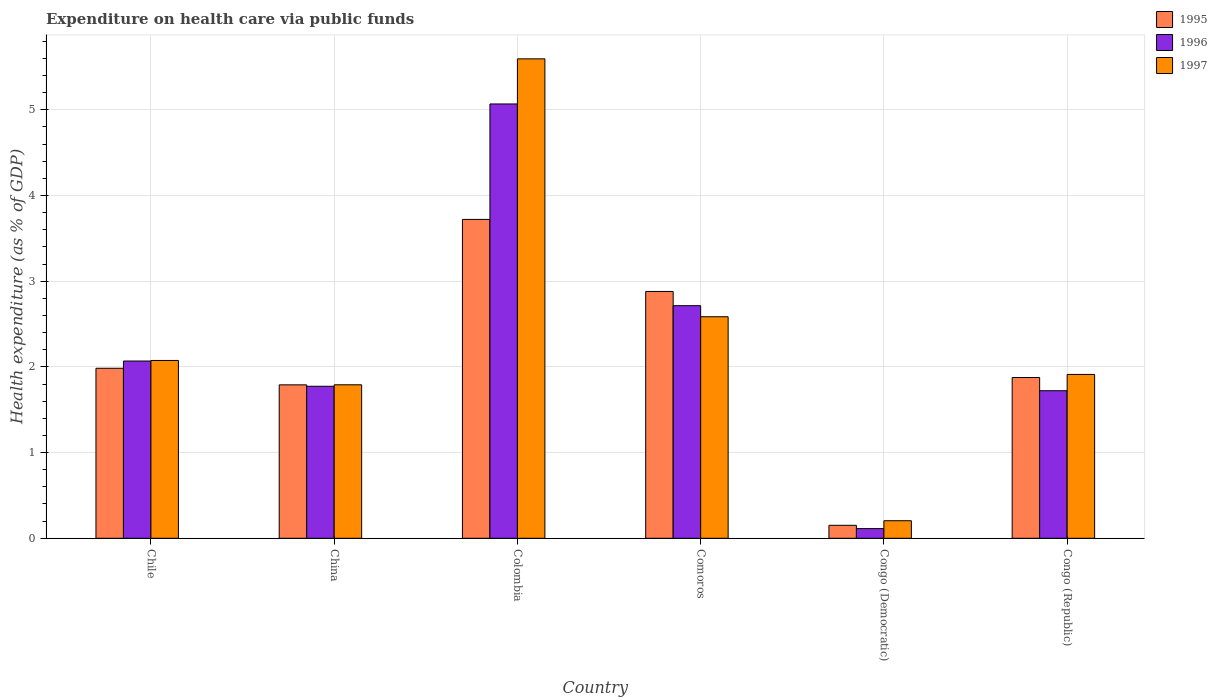Are the number of bars on each tick of the X-axis equal?
Give a very brief answer. Yes. How many bars are there on the 5th tick from the left?
Keep it short and to the point. 3. In how many cases, is the number of bars for a given country not equal to the number of legend labels?
Your answer should be very brief. 0. What is the expenditure made on health care in 1995 in China?
Provide a short and direct response. 1.79. Across all countries, what is the maximum expenditure made on health care in 1995?
Give a very brief answer. 3.72. Across all countries, what is the minimum expenditure made on health care in 1995?
Your answer should be very brief. 0.15. In which country was the expenditure made on health care in 1996 minimum?
Ensure brevity in your answer.  Congo (Democratic). What is the total expenditure made on health care in 1995 in the graph?
Keep it short and to the point. 12.4. What is the difference between the expenditure made on health care in 1995 in Colombia and that in Comoros?
Provide a succinct answer. 0.84. What is the difference between the expenditure made on health care in 1997 in Chile and the expenditure made on health care in 1995 in Congo (Republic)?
Keep it short and to the point. 0.2. What is the average expenditure made on health care in 1996 per country?
Offer a very short reply. 2.24. What is the difference between the expenditure made on health care of/in 1995 and expenditure made on health care of/in 1997 in Chile?
Your answer should be very brief. -0.09. What is the ratio of the expenditure made on health care in 1996 in Congo (Democratic) to that in Congo (Republic)?
Your response must be concise. 0.07. What is the difference between the highest and the second highest expenditure made on health care in 1996?
Make the answer very short. 0.65. What is the difference between the highest and the lowest expenditure made on health care in 1997?
Your answer should be compact. 5.39. What does the 2nd bar from the right in Congo (Democratic) represents?
Your answer should be very brief. 1996. How many countries are there in the graph?
Offer a very short reply. 6. What is the difference between two consecutive major ticks on the Y-axis?
Your response must be concise. 1. Does the graph contain grids?
Your answer should be compact. Yes. How are the legend labels stacked?
Keep it short and to the point. Vertical. What is the title of the graph?
Your response must be concise. Expenditure on health care via public funds. What is the label or title of the Y-axis?
Your response must be concise. Health expenditure (as % of GDP). What is the Health expenditure (as % of GDP) in 1995 in Chile?
Provide a short and direct response. 1.98. What is the Health expenditure (as % of GDP) of 1996 in Chile?
Your answer should be very brief. 2.07. What is the Health expenditure (as % of GDP) in 1997 in Chile?
Ensure brevity in your answer.  2.07. What is the Health expenditure (as % of GDP) of 1995 in China?
Keep it short and to the point. 1.79. What is the Health expenditure (as % of GDP) of 1996 in China?
Ensure brevity in your answer.  1.77. What is the Health expenditure (as % of GDP) of 1997 in China?
Make the answer very short. 1.79. What is the Health expenditure (as % of GDP) of 1995 in Colombia?
Provide a succinct answer. 3.72. What is the Health expenditure (as % of GDP) of 1996 in Colombia?
Keep it short and to the point. 5.07. What is the Health expenditure (as % of GDP) in 1997 in Colombia?
Your answer should be compact. 5.59. What is the Health expenditure (as % of GDP) of 1995 in Comoros?
Ensure brevity in your answer.  2.88. What is the Health expenditure (as % of GDP) in 1996 in Comoros?
Your answer should be very brief. 2.71. What is the Health expenditure (as % of GDP) in 1997 in Comoros?
Give a very brief answer. 2.58. What is the Health expenditure (as % of GDP) of 1995 in Congo (Democratic)?
Keep it short and to the point. 0.15. What is the Health expenditure (as % of GDP) of 1996 in Congo (Democratic)?
Your answer should be compact. 0.11. What is the Health expenditure (as % of GDP) of 1997 in Congo (Democratic)?
Offer a terse response. 0.2. What is the Health expenditure (as % of GDP) of 1995 in Congo (Republic)?
Your response must be concise. 1.88. What is the Health expenditure (as % of GDP) in 1996 in Congo (Republic)?
Your response must be concise. 1.72. What is the Health expenditure (as % of GDP) in 1997 in Congo (Republic)?
Keep it short and to the point. 1.91. Across all countries, what is the maximum Health expenditure (as % of GDP) in 1995?
Keep it short and to the point. 3.72. Across all countries, what is the maximum Health expenditure (as % of GDP) in 1996?
Your answer should be very brief. 5.07. Across all countries, what is the maximum Health expenditure (as % of GDP) of 1997?
Provide a succinct answer. 5.59. Across all countries, what is the minimum Health expenditure (as % of GDP) in 1995?
Offer a terse response. 0.15. Across all countries, what is the minimum Health expenditure (as % of GDP) in 1996?
Provide a succinct answer. 0.11. Across all countries, what is the minimum Health expenditure (as % of GDP) in 1997?
Offer a terse response. 0.2. What is the total Health expenditure (as % of GDP) in 1995 in the graph?
Your response must be concise. 12.4. What is the total Health expenditure (as % of GDP) of 1996 in the graph?
Your answer should be compact. 13.46. What is the total Health expenditure (as % of GDP) in 1997 in the graph?
Ensure brevity in your answer.  14.16. What is the difference between the Health expenditure (as % of GDP) in 1995 in Chile and that in China?
Your response must be concise. 0.19. What is the difference between the Health expenditure (as % of GDP) in 1996 in Chile and that in China?
Ensure brevity in your answer.  0.29. What is the difference between the Health expenditure (as % of GDP) in 1997 in Chile and that in China?
Provide a short and direct response. 0.28. What is the difference between the Health expenditure (as % of GDP) of 1995 in Chile and that in Colombia?
Provide a succinct answer. -1.74. What is the difference between the Health expenditure (as % of GDP) in 1996 in Chile and that in Colombia?
Your answer should be compact. -3. What is the difference between the Health expenditure (as % of GDP) in 1997 in Chile and that in Colombia?
Provide a succinct answer. -3.52. What is the difference between the Health expenditure (as % of GDP) of 1995 in Chile and that in Comoros?
Your response must be concise. -0.9. What is the difference between the Health expenditure (as % of GDP) in 1996 in Chile and that in Comoros?
Make the answer very short. -0.65. What is the difference between the Health expenditure (as % of GDP) of 1997 in Chile and that in Comoros?
Offer a terse response. -0.51. What is the difference between the Health expenditure (as % of GDP) in 1995 in Chile and that in Congo (Democratic)?
Your answer should be compact. 1.83. What is the difference between the Health expenditure (as % of GDP) in 1996 in Chile and that in Congo (Democratic)?
Offer a very short reply. 1.96. What is the difference between the Health expenditure (as % of GDP) of 1997 in Chile and that in Congo (Democratic)?
Your response must be concise. 1.87. What is the difference between the Health expenditure (as % of GDP) in 1995 in Chile and that in Congo (Republic)?
Provide a short and direct response. 0.11. What is the difference between the Health expenditure (as % of GDP) in 1996 in Chile and that in Congo (Republic)?
Your response must be concise. 0.35. What is the difference between the Health expenditure (as % of GDP) of 1997 in Chile and that in Congo (Republic)?
Your answer should be compact. 0.16. What is the difference between the Health expenditure (as % of GDP) in 1995 in China and that in Colombia?
Your answer should be compact. -1.93. What is the difference between the Health expenditure (as % of GDP) of 1996 in China and that in Colombia?
Offer a very short reply. -3.29. What is the difference between the Health expenditure (as % of GDP) in 1997 in China and that in Colombia?
Your answer should be very brief. -3.8. What is the difference between the Health expenditure (as % of GDP) of 1995 in China and that in Comoros?
Your response must be concise. -1.09. What is the difference between the Health expenditure (as % of GDP) in 1996 in China and that in Comoros?
Provide a short and direct response. -0.94. What is the difference between the Health expenditure (as % of GDP) of 1997 in China and that in Comoros?
Provide a succinct answer. -0.79. What is the difference between the Health expenditure (as % of GDP) of 1995 in China and that in Congo (Democratic)?
Provide a short and direct response. 1.64. What is the difference between the Health expenditure (as % of GDP) of 1996 in China and that in Congo (Democratic)?
Ensure brevity in your answer.  1.66. What is the difference between the Health expenditure (as % of GDP) in 1997 in China and that in Congo (Democratic)?
Ensure brevity in your answer.  1.59. What is the difference between the Health expenditure (as % of GDP) of 1995 in China and that in Congo (Republic)?
Your answer should be very brief. -0.09. What is the difference between the Health expenditure (as % of GDP) in 1996 in China and that in Congo (Republic)?
Your answer should be very brief. 0.05. What is the difference between the Health expenditure (as % of GDP) of 1997 in China and that in Congo (Republic)?
Your answer should be compact. -0.12. What is the difference between the Health expenditure (as % of GDP) of 1995 in Colombia and that in Comoros?
Make the answer very short. 0.84. What is the difference between the Health expenditure (as % of GDP) in 1996 in Colombia and that in Comoros?
Provide a succinct answer. 2.35. What is the difference between the Health expenditure (as % of GDP) of 1997 in Colombia and that in Comoros?
Offer a very short reply. 3.01. What is the difference between the Health expenditure (as % of GDP) of 1995 in Colombia and that in Congo (Democratic)?
Your answer should be very brief. 3.57. What is the difference between the Health expenditure (as % of GDP) in 1996 in Colombia and that in Congo (Democratic)?
Your answer should be very brief. 4.95. What is the difference between the Health expenditure (as % of GDP) in 1997 in Colombia and that in Congo (Democratic)?
Provide a short and direct response. 5.39. What is the difference between the Health expenditure (as % of GDP) in 1995 in Colombia and that in Congo (Republic)?
Your response must be concise. 1.84. What is the difference between the Health expenditure (as % of GDP) of 1996 in Colombia and that in Congo (Republic)?
Your response must be concise. 3.35. What is the difference between the Health expenditure (as % of GDP) in 1997 in Colombia and that in Congo (Republic)?
Keep it short and to the point. 3.68. What is the difference between the Health expenditure (as % of GDP) of 1995 in Comoros and that in Congo (Democratic)?
Your answer should be very brief. 2.73. What is the difference between the Health expenditure (as % of GDP) in 1996 in Comoros and that in Congo (Democratic)?
Your response must be concise. 2.6. What is the difference between the Health expenditure (as % of GDP) of 1997 in Comoros and that in Congo (Democratic)?
Offer a very short reply. 2.38. What is the difference between the Health expenditure (as % of GDP) in 1995 in Comoros and that in Congo (Republic)?
Your answer should be compact. 1. What is the difference between the Health expenditure (as % of GDP) in 1997 in Comoros and that in Congo (Republic)?
Ensure brevity in your answer.  0.67. What is the difference between the Health expenditure (as % of GDP) in 1995 in Congo (Democratic) and that in Congo (Republic)?
Give a very brief answer. -1.72. What is the difference between the Health expenditure (as % of GDP) in 1996 in Congo (Democratic) and that in Congo (Republic)?
Keep it short and to the point. -1.61. What is the difference between the Health expenditure (as % of GDP) of 1997 in Congo (Democratic) and that in Congo (Republic)?
Offer a very short reply. -1.71. What is the difference between the Health expenditure (as % of GDP) in 1995 in Chile and the Health expenditure (as % of GDP) in 1996 in China?
Give a very brief answer. 0.21. What is the difference between the Health expenditure (as % of GDP) in 1995 in Chile and the Health expenditure (as % of GDP) in 1997 in China?
Give a very brief answer. 0.19. What is the difference between the Health expenditure (as % of GDP) of 1996 in Chile and the Health expenditure (as % of GDP) of 1997 in China?
Your answer should be very brief. 0.28. What is the difference between the Health expenditure (as % of GDP) in 1995 in Chile and the Health expenditure (as % of GDP) in 1996 in Colombia?
Your response must be concise. -3.08. What is the difference between the Health expenditure (as % of GDP) in 1995 in Chile and the Health expenditure (as % of GDP) in 1997 in Colombia?
Your answer should be compact. -3.61. What is the difference between the Health expenditure (as % of GDP) in 1996 in Chile and the Health expenditure (as % of GDP) in 1997 in Colombia?
Provide a short and direct response. -3.53. What is the difference between the Health expenditure (as % of GDP) of 1995 in Chile and the Health expenditure (as % of GDP) of 1996 in Comoros?
Provide a short and direct response. -0.73. What is the difference between the Health expenditure (as % of GDP) in 1995 in Chile and the Health expenditure (as % of GDP) in 1997 in Comoros?
Offer a terse response. -0.6. What is the difference between the Health expenditure (as % of GDP) in 1996 in Chile and the Health expenditure (as % of GDP) in 1997 in Comoros?
Your answer should be very brief. -0.52. What is the difference between the Health expenditure (as % of GDP) of 1995 in Chile and the Health expenditure (as % of GDP) of 1996 in Congo (Democratic)?
Provide a succinct answer. 1.87. What is the difference between the Health expenditure (as % of GDP) in 1995 in Chile and the Health expenditure (as % of GDP) in 1997 in Congo (Democratic)?
Offer a very short reply. 1.78. What is the difference between the Health expenditure (as % of GDP) of 1996 in Chile and the Health expenditure (as % of GDP) of 1997 in Congo (Democratic)?
Provide a succinct answer. 1.86. What is the difference between the Health expenditure (as % of GDP) of 1995 in Chile and the Health expenditure (as % of GDP) of 1996 in Congo (Republic)?
Offer a terse response. 0.26. What is the difference between the Health expenditure (as % of GDP) of 1995 in Chile and the Health expenditure (as % of GDP) of 1997 in Congo (Republic)?
Ensure brevity in your answer.  0.07. What is the difference between the Health expenditure (as % of GDP) of 1996 in Chile and the Health expenditure (as % of GDP) of 1997 in Congo (Republic)?
Provide a short and direct response. 0.16. What is the difference between the Health expenditure (as % of GDP) of 1995 in China and the Health expenditure (as % of GDP) of 1996 in Colombia?
Provide a succinct answer. -3.28. What is the difference between the Health expenditure (as % of GDP) in 1995 in China and the Health expenditure (as % of GDP) in 1997 in Colombia?
Your answer should be very brief. -3.8. What is the difference between the Health expenditure (as % of GDP) of 1996 in China and the Health expenditure (as % of GDP) of 1997 in Colombia?
Give a very brief answer. -3.82. What is the difference between the Health expenditure (as % of GDP) in 1995 in China and the Health expenditure (as % of GDP) in 1996 in Comoros?
Offer a terse response. -0.92. What is the difference between the Health expenditure (as % of GDP) in 1995 in China and the Health expenditure (as % of GDP) in 1997 in Comoros?
Keep it short and to the point. -0.79. What is the difference between the Health expenditure (as % of GDP) of 1996 in China and the Health expenditure (as % of GDP) of 1997 in Comoros?
Offer a terse response. -0.81. What is the difference between the Health expenditure (as % of GDP) of 1995 in China and the Health expenditure (as % of GDP) of 1996 in Congo (Democratic)?
Make the answer very short. 1.68. What is the difference between the Health expenditure (as % of GDP) of 1995 in China and the Health expenditure (as % of GDP) of 1997 in Congo (Democratic)?
Offer a very short reply. 1.59. What is the difference between the Health expenditure (as % of GDP) of 1996 in China and the Health expenditure (as % of GDP) of 1997 in Congo (Democratic)?
Ensure brevity in your answer.  1.57. What is the difference between the Health expenditure (as % of GDP) of 1995 in China and the Health expenditure (as % of GDP) of 1996 in Congo (Republic)?
Your answer should be very brief. 0.07. What is the difference between the Health expenditure (as % of GDP) in 1995 in China and the Health expenditure (as % of GDP) in 1997 in Congo (Republic)?
Provide a short and direct response. -0.12. What is the difference between the Health expenditure (as % of GDP) of 1996 in China and the Health expenditure (as % of GDP) of 1997 in Congo (Republic)?
Provide a short and direct response. -0.14. What is the difference between the Health expenditure (as % of GDP) in 1995 in Colombia and the Health expenditure (as % of GDP) in 1996 in Comoros?
Provide a short and direct response. 1.01. What is the difference between the Health expenditure (as % of GDP) in 1995 in Colombia and the Health expenditure (as % of GDP) in 1997 in Comoros?
Your answer should be compact. 1.14. What is the difference between the Health expenditure (as % of GDP) of 1996 in Colombia and the Health expenditure (as % of GDP) of 1997 in Comoros?
Offer a terse response. 2.48. What is the difference between the Health expenditure (as % of GDP) in 1995 in Colombia and the Health expenditure (as % of GDP) in 1996 in Congo (Democratic)?
Provide a short and direct response. 3.61. What is the difference between the Health expenditure (as % of GDP) of 1995 in Colombia and the Health expenditure (as % of GDP) of 1997 in Congo (Democratic)?
Your response must be concise. 3.52. What is the difference between the Health expenditure (as % of GDP) of 1996 in Colombia and the Health expenditure (as % of GDP) of 1997 in Congo (Democratic)?
Provide a succinct answer. 4.86. What is the difference between the Health expenditure (as % of GDP) of 1995 in Colombia and the Health expenditure (as % of GDP) of 1996 in Congo (Republic)?
Make the answer very short. 2. What is the difference between the Health expenditure (as % of GDP) of 1995 in Colombia and the Health expenditure (as % of GDP) of 1997 in Congo (Republic)?
Keep it short and to the point. 1.81. What is the difference between the Health expenditure (as % of GDP) in 1996 in Colombia and the Health expenditure (as % of GDP) in 1997 in Congo (Republic)?
Your answer should be very brief. 3.16. What is the difference between the Health expenditure (as % of GDP) of 1995 in Comoros and the Health expenditure (as % of GDP) of 1996 in Congo (Democratic)?
Your response must be concise. 2.77. What is the difference between the Health expenditure (as % of GDP) in 1995 in Comoros and the Health expenditure (as % of GDP) in 1997 in Congo (Democratic)?
Keep it short and to the point. 2.67. What is the difference between the Health expenditure (as % of GDP) in 1996 in Comoros and the Health expenditure (as % of GDP) in 1997 in Congo (Democratic)?
Keep it short and to the point. 2.51. What is the difference between the Health expenditure (as % of GDP) in 1995 in Comoros and the Health expenditure (as % of GDP) in 1996 in Congo (Republic)?
Provide a short and direct response. 1.16. What is the difference between the Health expenditure (as % of GDP) in 1995 in Comoros and the Health expenditure (as % of GDP) in 1997 in Congo (Republic)?
Provide a short and direct response. 0.97. What is the difference between the Health expenditure (as % of GDP) in 1996 in Comoros and the Health expenditure (as % of GDP) in 1997 in Congo (Republic)?
Your answer should be compact. 0.8. What is the difference between the Health expenditure (as % of GDP) of 1995 in Congo (Democratic) and the Health expenditure (as % of GDP) of 1996 in Congo (Republic)?
Your response must be concise. -1.57. What is the difference between the Health expenditure (as % of GDP) in 1995 in Congo (Democratic) and the Health expenditure (as % of GDP) in 1997 in Congo (Republic)?
Provide a short and direct response. -1.76. What is the difference between the Health expenditure (as % of GDP) of 1996 in Congo (Democratic) and the Health expenditure (as % of GDP) of 1997 in Congo (Republic)?
Your response must be concise. -1.8. What is the average Health expenditure (as % of GDP) in 1995 per country?
Give a very brief answer. 2.07. What is the average Health expenditure (as % of GDP) in 1996 per country?
Offer a very short reply. 2.24. What is the average Health expenditure (as % of GDP) in 1997 per country?
Give a very brief answer. 2.36. What is the difference between the Health expenditure (as % of GDP) in 1995 and Health expenditure (as % of GDP) in 1996 in Chile?
Provide a short and direct response. -0.08. What is the difference between the Health expenditure (as % of GDP) of 1995 and Health expenditure (as % of GDP) of 1997 in Chile?
Your answer should be compact. -0.09. What is the difference between the Health expenditure (as % of GDP) of 1996 and Health expenditure (as % of GDP) of 1997 in Chile?
Give a very brief answer. -0.01. What is the difference between the Health expenditure (as % of GDP) in 1995 and Health expenditure (as % of GDP) in 1996 in China?
Offer a very short reply. 0.02. What is the difference between the Health expenditure (as % of GDP) in 1995 and Health expenditure (as % of GDP) in 1997 in China?
Ensure brevity in your answer.  -0. What is the difference between the Health expenditure (as % of GDP) in 1996 and Health expenditure (as % of GDP) in 1997 in China?
Keep it short and to the point. -0.02. What is the difference between the Health expenditure (as % of GDP) of 1995 and Health expenditure (as % of GDP) of 1996 in Colombia?
Your answer should be very brief. -1.35. What is the difference between the Health expenditure (as % of GDP) in 1995 and Health expenditure (as % of GDP) in 1997 in Colombia?
Your answer should be compact. -1.87. What is the difference between the Health expenditure (as % of GDP) of 1996 and Health expenditure (as % of GDP) of 1997 in Colombia?
Your answer should be very brief. -0.53. What is the difference between the Health expenditure (as % of GDP) of 1995 and Health expenditure (as % of GDP) of 1996 in Comoros?
Offer a terse response. 0.17. What is the difference between the Health expenditure (as % of GDP) of 1995 and Health expenditure (as % of GDP) of 1997 in Comoros?
Provide a succinct answer. 0.29. What is the difference between the Health expenditure (as % of GDP) of 1996 and Health expenditure (as % of GDP) of 1997 in Comoros?
Give a very brief answer. 0.13. What is the difference between the Health expenditure (as % of GDP) of 1995 and Health expenditure (as % of GDP) of 1996 in Congo (Democratic)?
Ensure brevity in your answer.  0.04. What is the difference between the Health expenditure (as % of GDP) in 1995 and Health expenditure (as % of GDP) in 1997 in Congo (Democratic)?
Make the answer very short. -0.05. What is the difference between the Health expenditure (as % of GDP) in 1996 and Health expenditure (as % of GDP) in 1997 in Congo (Democratic)?
Provide a short and direct response. -0.09. What is the difference between the Health expenditure (as % of GDP) in 1995 and Health expenditure (as % of GDP) in 1996 in Congo (Republic)?
Provide a succinct answer. 0.15. What is the difference between the Health expenditure (as % of GDP) in 1995 and Health expenditure (as % of GDP) in 1997 in Congo (Republic)?
Offer a terse response. -0.04. What is the difference between the Health expenditure (as % of GDP) in 1996 and Health expenditure (as % of GDP) in 1997 in Congo (Republic)?
Your response must be concise. -0.19. What is the ratio of the Health expenditure (as % of GDP) of 1995 in Chile to that in China?
Make the answer very short. 1.11. What is the ratio of the Health expenditure (as % of GDP) of 1996 in Chile to that in China?
Provide a short and direct response. 1.17. What is the ratio of the Health expenditure (as % of GDP) in 1997 in Chile to that in China?
Make the answer very short. 1.16. What is the ratio of the Health expenditure (as % of GDP) in 1995 in Chile to that in Colombia?
Give a very brief answer. 0.53. What is the ratio of the Health expenditure (as % of GDP) in 1996 in Chile to that in Colombia?
Provide a succinct answer. 0.41. What is the ratio of the Health expenditure (as % of GDP) in 1997 in Chile to that in Colombia?
Your answer should be compact. 0.37. What is the ratio of the Health expenditure (as % of GDP) in 1995 in Chile to that in Comoros?
Keep it short and to the point. 0.69. What is the ratio of the Health expenditure (as % of GDP) in 1996 in Chile to that in Comoros?
Keep it short and to the point. 0.76. What is the ratio of the Health expenditure (as % of GDP) of 1997 in Chile to that in Comoros?
Offer a terse response. 0.8. What is the ratio of the Health expenditure (as % of GDP) in 1995 in Chile to that in Congo (Democratic)?
Ensure brevity in your answer.  13.1. What is the ratio of the Health expenditure (as % of GDP) of 1996 in Chile to that in Congo (Democratic)?
Your response must be concise. 18.3. What is the ratio of the Health expenditure (as % of GDP) of 1997 in Chile to that in Congo (Democratic)?
Your response must be concise. 10.13. What is the ratio of the Health expenditure (as % of GDP) of 1995 in Chile to that in Congo (Republic)?
Your answer should be very brief. 1.06. What is the ratio of the Health expenditure (as % of GDP) of 1996 in Chile to that in Congo (Republic)?
Keep it short and to the point. 1.2. What is the ratio of the Health expenditure (as % of GDP) in 1997 in Chile to that in Congo (Republic)?
Your answer should be compact. 1.09. What is the ratio of the Health expenditure (as % of GDP) in 1995 in China to that in Colombia?
Offer a very short reply. 0.48. What is the ratio of the Health expenditure (as % of GDP) of 1997 in China to that in Colombia?
Keep it short and to the point. 0.32. What is the ratio of the Health expenditure (as % of GDP) in 1995 in China to that in Comoros?
Your answer should be very brief. 0.62. What is the ratio of the Health expenditure (as % of GDP) of 1996 in China to that in Comoros?
Provide a succinct answer. 0.65. What is the ratio of the Health expenditure (as % of GDP) in 1997 in China to that in Comoros?
Ensure brevity in your answer.  0.69. What is the ratio of the Health expenditure (as % of GDP) of 1995 in China to that in Congo (Democratic)?
Ensure brevity in your answer.  11.82. What is the ratio of the Health expenditure (as % of GDP) in 1996 in China to that in Congo (Democratic)?
Your response must be concise. 15.69. What is the ratio of the Health expenditure (as % of GDP) of 1997 in China to that in Congo (Democratic)?
Ensure brevity in your answer.  8.74. What is the ratio of the Health expenditure (as % of GDP) of 1995 in China to that in Congo (Republic)?
Your answer should be very brief. 0.95. What is the ratio of the Health expenditure (as % of GDP) of 1996 in China to that in Congo (Republic)?
Your answer should be very brief. 1.03. What is the ratio of the Health expenditure (as % of GDP) in 1997 in China to that in Congo (Republic)?
Offer a terse response. 0.94. What is the ratio of the Health expenditure (as % of GDP) in 1995 in Colombia to that in Comoros?
Provide a succinct answer. 1.29. What is the ratio of the Health expenditure (as % of GDP) of 1996 in Colombia to that in Comoros?
Offer a terse response. 1.87. What is the ratio of the Health expenditure (as % of GDP) in 1997 in Colombia to that in Comoros?
Your answer should be compact. 2.16. What is the ratio of the Health expenditure (as % of GDP) in 1995 in Colombia to that in Congo (Democratic)?
Your answer should be very brief. 24.56. What is the ratio of the Health expenditure (as % of GDP) in 1996 in Colombia to that in Congo (Democratic)?
Offer a very short reply. 44.84. What is the ratio of the Health expenditure (as % of GDP) in 1997 in Colombia to that in Congo (Democratic)?
Keep it short and to the point. 27.3. What is the ratio of the Health expenditure (as % of GDP) of 1995 in Colombia to that in Congo (Republic)?
Offer a very short reply. 1.98. What is the ratio of the Health expenditure (as % of GDP) of 1996 in Colombia to that in Congo (Republic)?
Your answer should be compact. 2.94. What is the ratio of the Health expenditure (as % of GDP) in 1997 in Colombia to that in Congo (Republic)?
Offer a terse response. 2.93. What is the ratio of the Health expenditure (as % of GDP) in 1995 in Comoros to that in Congo (Democratic)?
Ensure brevity in your answer.  19.01. What is the ratio of the Health expenditure (as % of GDP) in 1996 in Comoros to that in Congo (Democratic)?
Your answer should be compact. 24.01. What is the ratio of the Health expenditure (as % of GDP) of 1997 in Comoros to that in Congo (Democratic)?
Offer a very short reply. 12.62. What is the ratio of the Health expenditure (as % of GDP) of 1995 in Comoros to that in Congo (Republic)?
Offer a terse response. 1.54. What is the ratio of the Health expenditure (as % of GDP) in 1996 in Comoros to that in Congo (Republic)?
Your answer should be compact. 1.58. What is the ratio of the Health expenditure (as % of GDP) of 1997 in Comoros to that in Congo (Republic)?
Provide a short and direct response. 1.35. What is the ratio of the Health expenditure (as % of GDP) in 1995 in Congo (Democratic) to that in Congo (Republic)?
Offer a very short reply. 0.08. What is the ratio of the Health expenditure (as % of GDP) in 1996 in Congo (Democratic) to that in Congo (Republic)?
Your answer should be compact. 0.07. What is the ratio of the Health expenditure (as % of GDP) in 1997 in Congo (Democratic) to that in Congo (Republic)?
Offer a very short reply. 0.11. What is the difference between the highest and the second highest Health expenditure (as % of GDP) in 1995?
Give a very brief answer. 0.84. What is the difference between the highest and the second highest Health expenditure (as % of GDP) of 1996?
Your response must be concise. 2.35. What is the difference between the highest and the second highest Health expenditure (as % of GDP) of 1997?
Offer a very short reply. 3.01. What is the difference between the highest and the lowest Health expenditure (as % of GDP) of 1995?
Ensure brevity in your answer.  3.57. What is the difference between the highest and the lowest Health expenditure (as % of GDP) in 1996?
Give a very brief answer. 4.95. What is the difference between the highest and the lowest Health expenditure (as % of GDP) in 1997?
Provide a short and direct response. 5.39. 